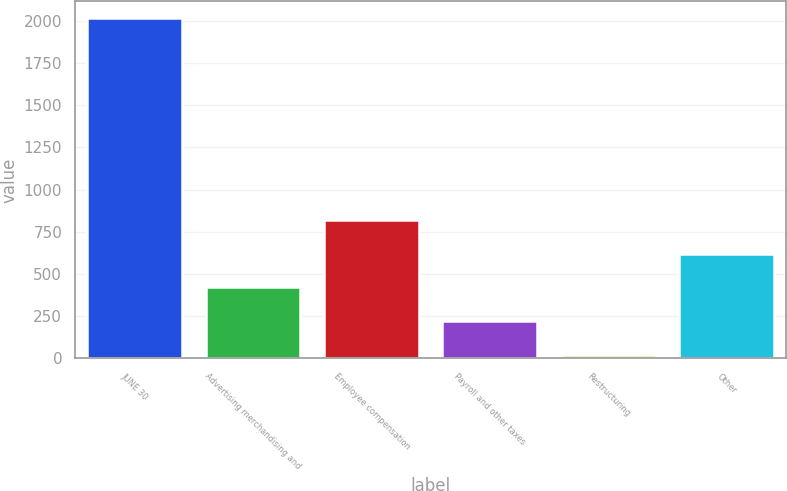Convert chart. <chart><loc_0><loc_0><loc_500><loc_500><bar_chart><fcel>JUNE 30<fcel>Advertising merchandising and<fcel>Employee compensation<fcel>Payroll and other taxes<fcel>Restructuring<fcel>Other<nl><fcel>2013<fcel>421.16<fcel>819.12<fcel>222.18<fcel>23.2<fcel>620.14<nl></chart> 